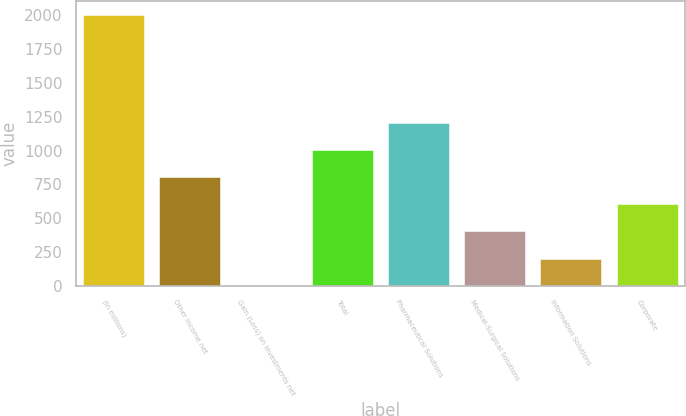<chart> <loc_0><loc_0><loc_500><loc_500><bar_chart><fcel>(In millions)<fcel>Other Income net<fcel>Gain (Loss) on Investments net<fcel>Total<fcel>Pharmaceutical Solutions<fcel>Medical-Surgical Solutions<fcel>Information Solutions<fcel>Corporate<nl><fcel>2003<fcel>802.04<fcel>1.4<fcel>1002.2<fcel>1202.36<fcel>401.72<fcel>201.56<fcel>601.88<nl></chart> 